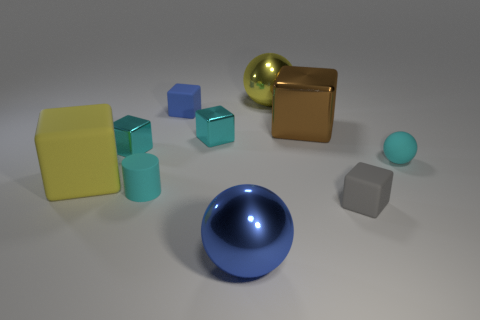Subtract 2 blocks. How many blocks are left? 4 Subtract all cyan cubes. How many cubes are left? 4 Subtract all tiny matte blocks. How many blocks are left? 4 Subtract all purple balls. Subtract all red cylinders. How many balls are left? 3 Subtract all cylinders. How many objects are left? 9 Add 1 blue metallic balls. How many blue metallic balls are left? 2 Add 3 big metallic blocks. How many big metallic blocks exist? 4 Subtract 0 red balls. How many objects are left? 10 Subtract all tiny purple shiny balls. Subtract all small cyan shiny blocks. How many objects are left? 8 